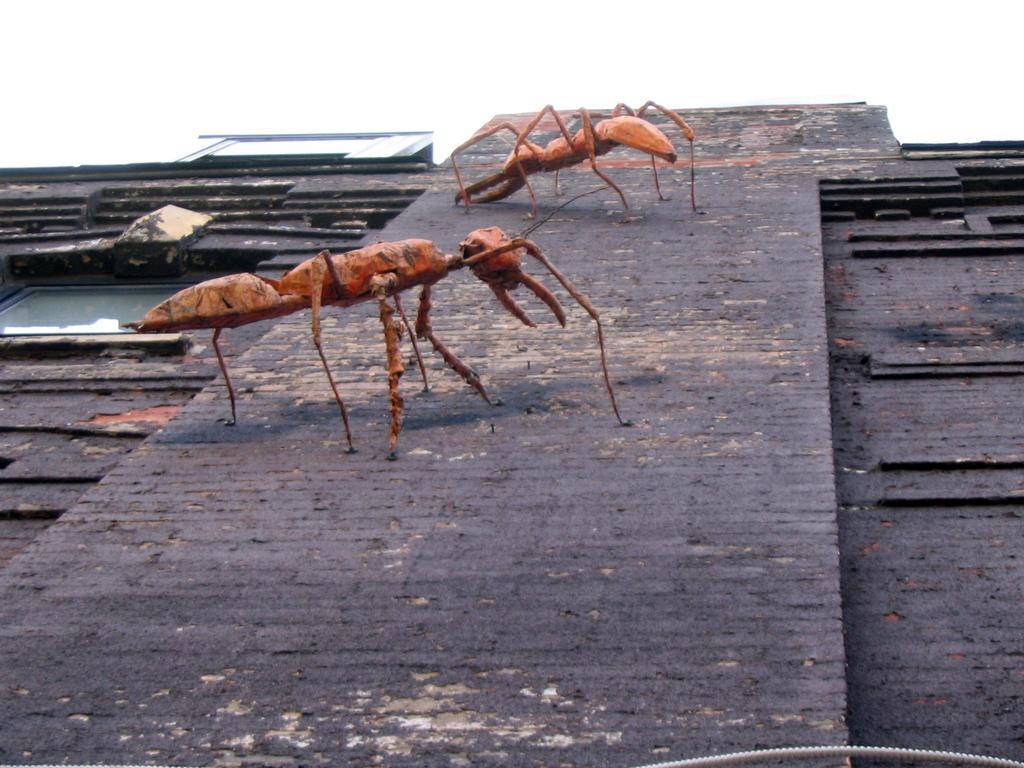Describe this image in one or two sentences. In this picture I can observe two ants. These are in red color. These are on the brown color surface. In the background there is a sky. 